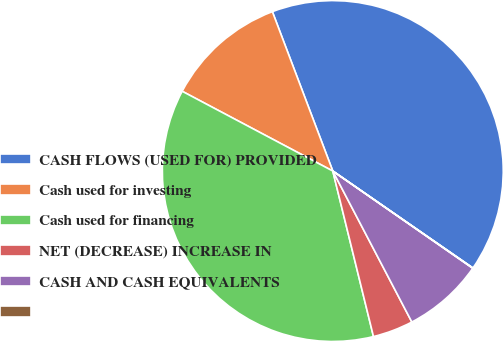Convert chart to OTSL. <chart><loc_0><loc_0><loc_500><loc_500><pie_chart><fcel>CASH FLOWS (USED FOR) PROVIDED<fcel>Cash used for investing<fcel>Cash used for financing<fcel>NET (DECREASE) INCREASE IN<fcel>CASH AND CASH EQUIVALENTS<fcel>Unnamed: 5<nl><fcel>40.4%<fcel>11.48%<fcel>36.59%<fcel>3.84%<fcel>7.66%<fcel>0.03%<nl></chart> 